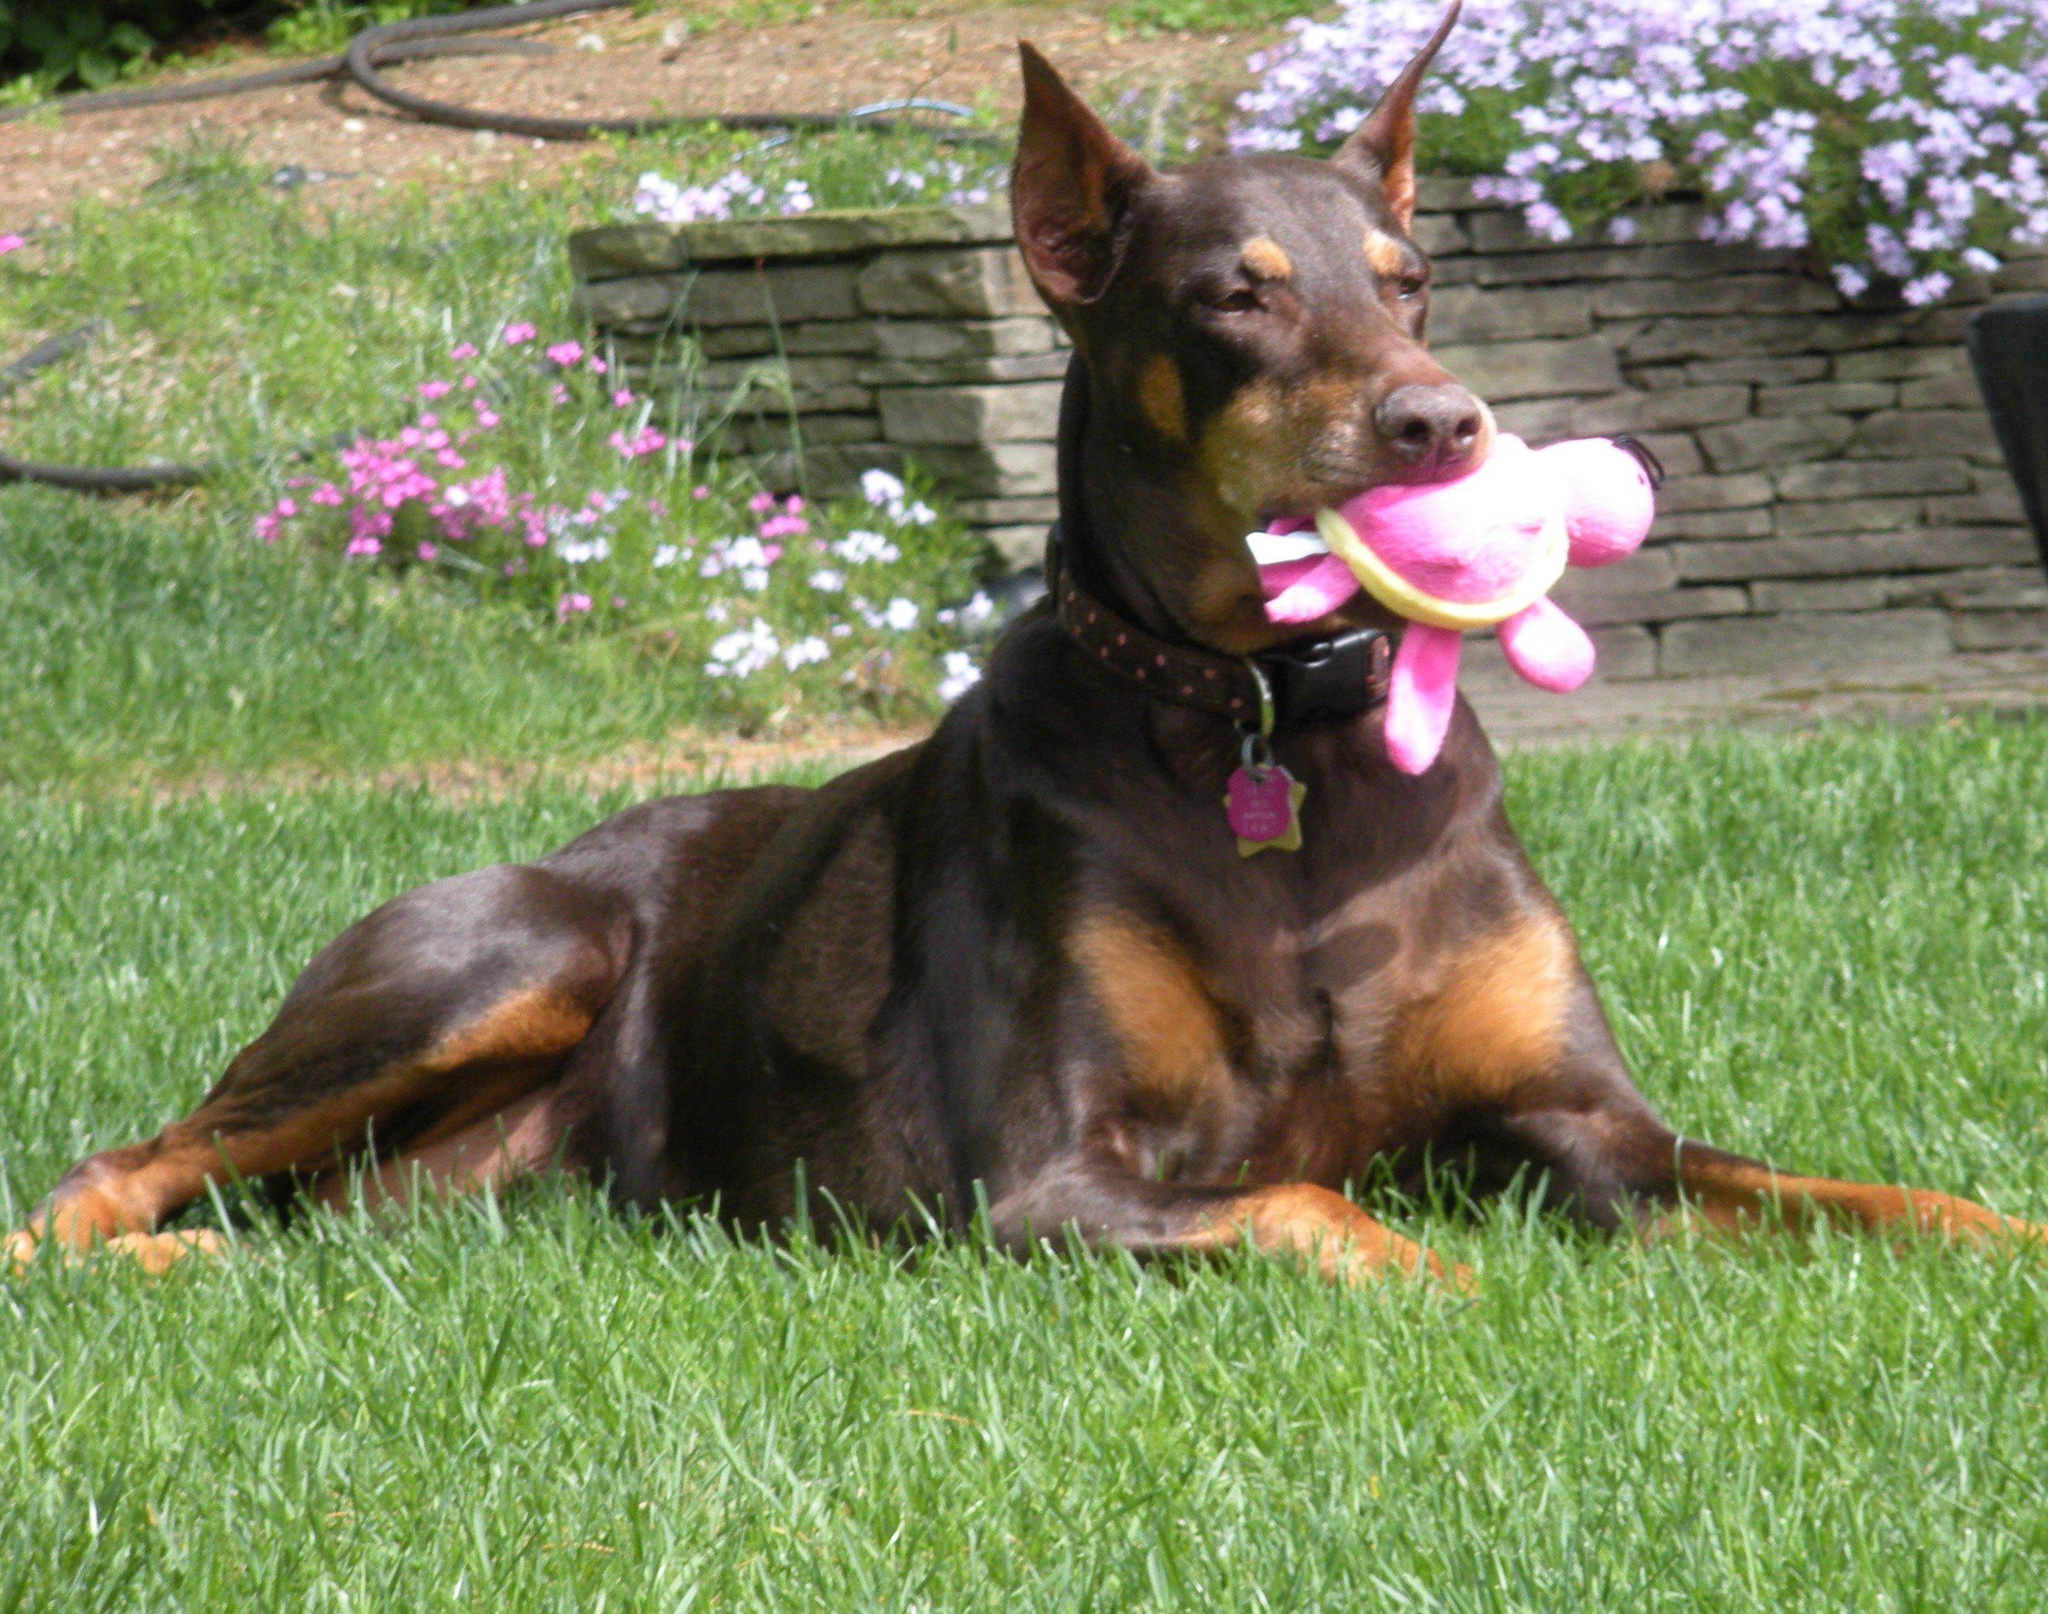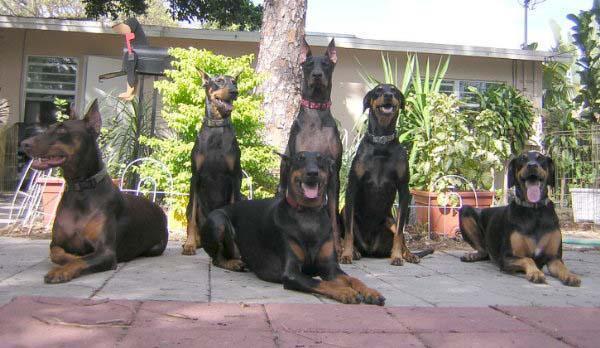The first image is the image on the left, the second image is the image on the right. Given the left and right images, does the statement "The right image contains no more than three dogs." hold true? Answer yes or no. No. The first image is the image on the left, the second image is the image on the right. Considering the images on both sides, is "The left image contains one rightward-gazing doberman with erect ears, and the right image features a reclining doberman accompanied by at least three other dogs." valid? Answer yes or no. Yes. 